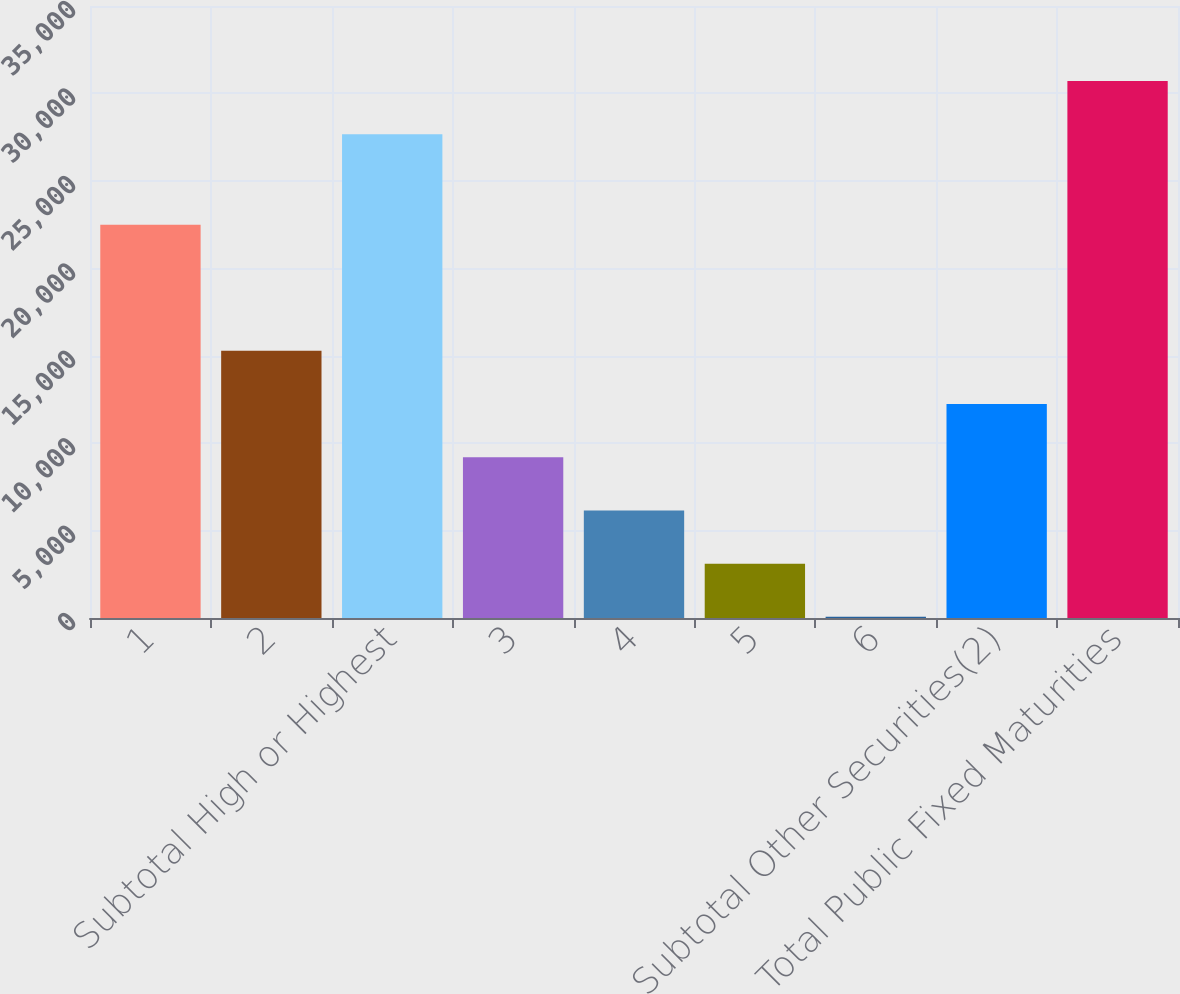Convert chart to OTSL. <chart><loc_0><loc_0><loc_500><loc_500><bar_chart><fcel>1<fcel>2<fcel>Subtotal High or Highest<fcel>3<fcel>4<fcel>5<fcel>6<fcel>Subtotal Other Securities(2)<fcel>Total Public Fixed Maturities<nl><fcel>22489<fcel>15282<fcel>27666<fcel>9195.2<fcel>6151.8<fcel>3108.4<fcel>65<fcel>12238.6<fcel>30709.4<nl></chart> 